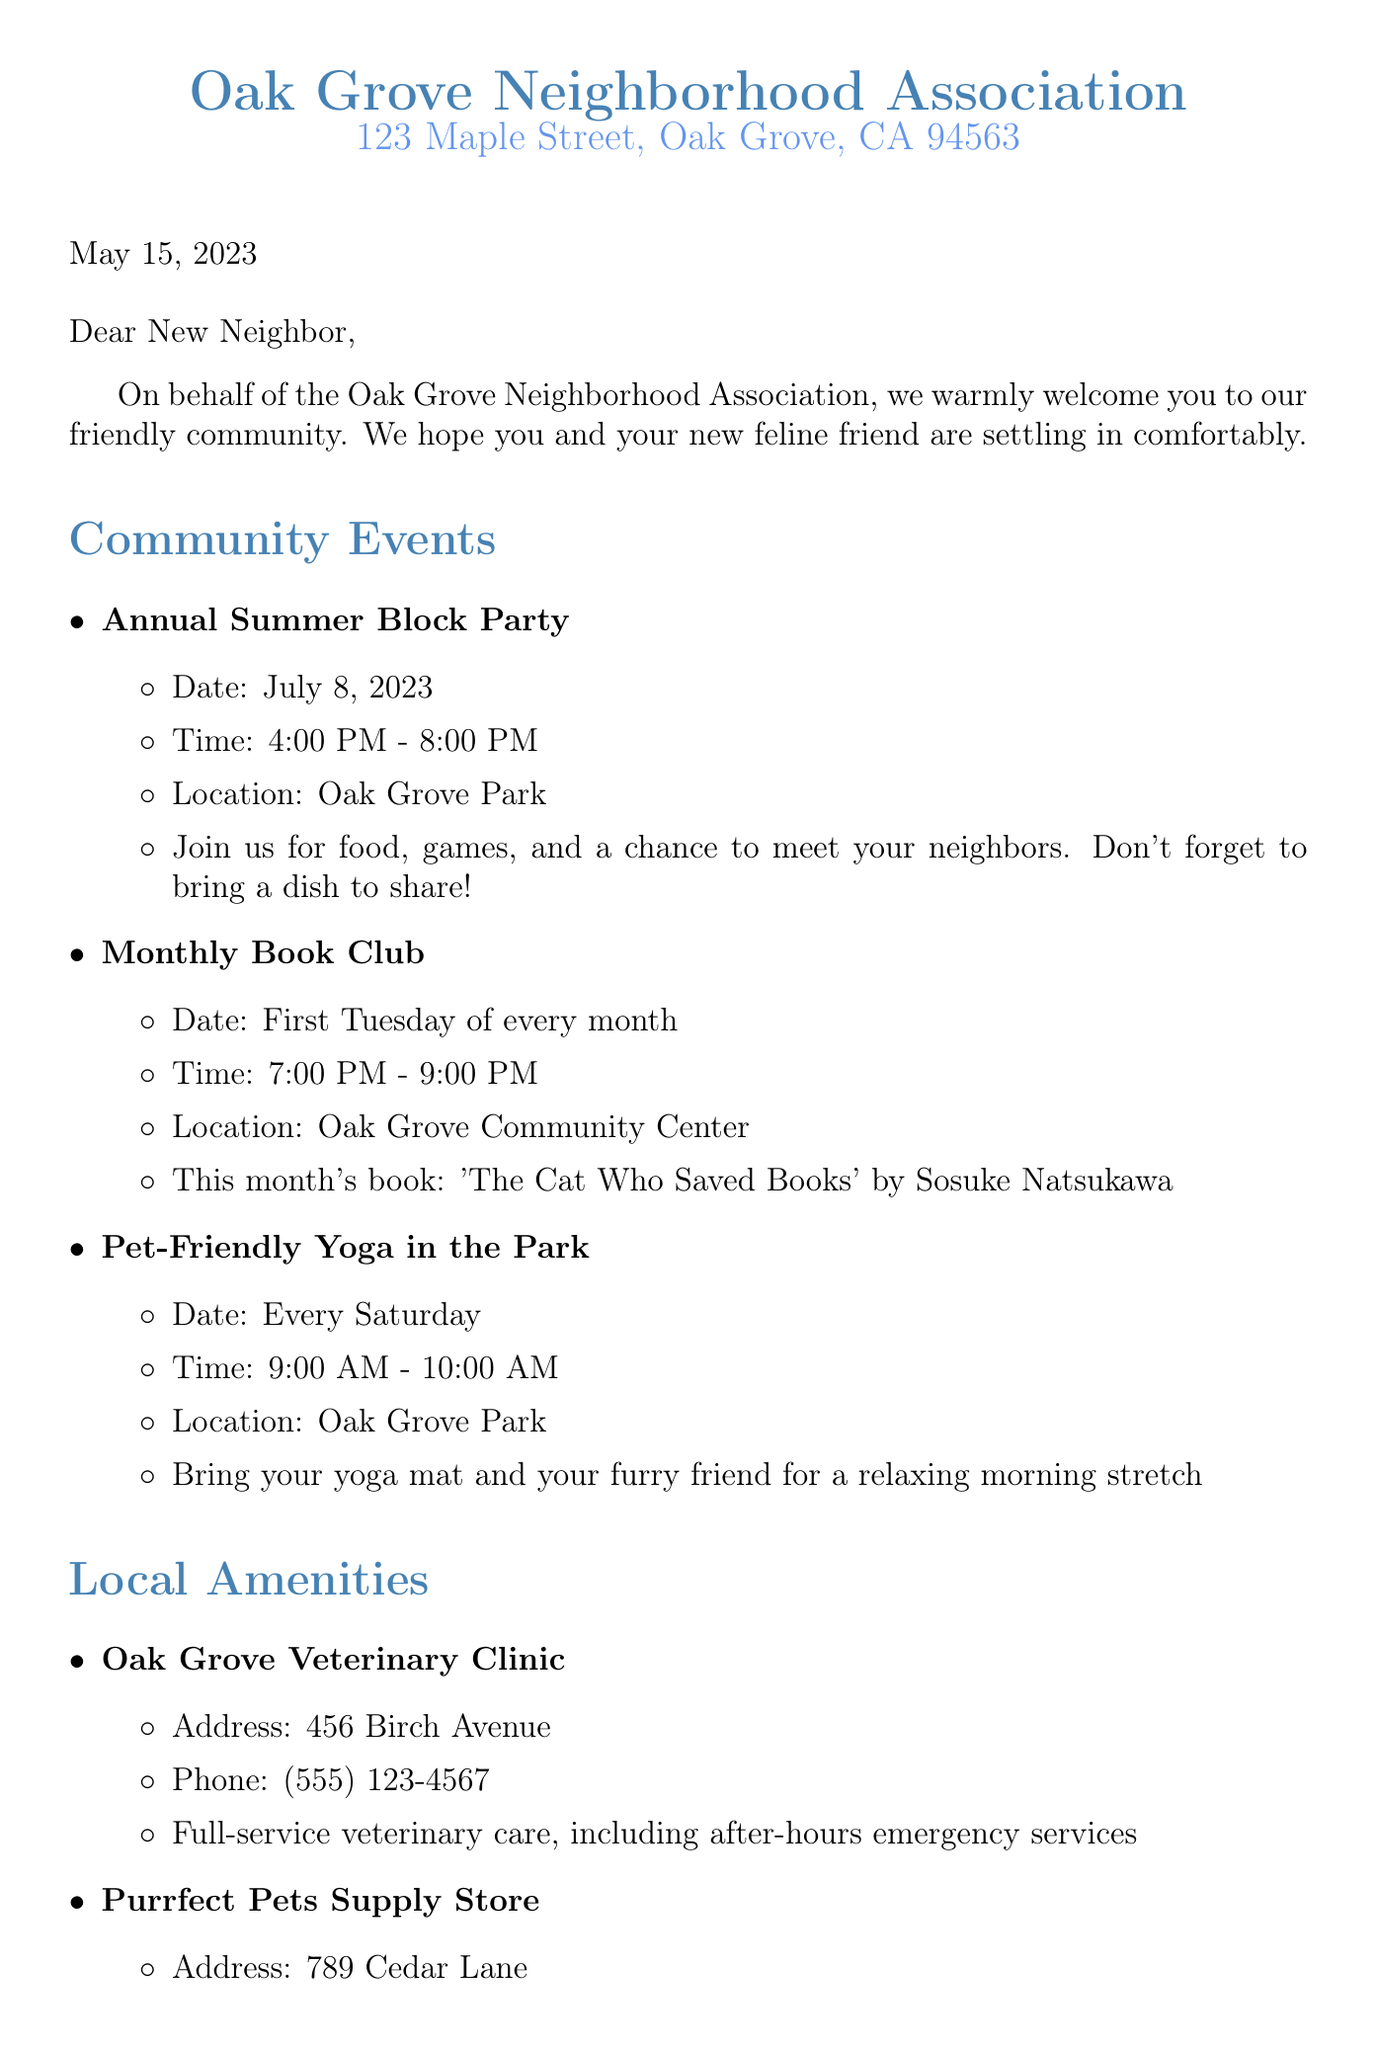What is the name of the neighborhood association? The document states that the name of the association is "Oak Grove Neighborhood Association."
Answer: Oak Grove Neighborhood Association What is the date of the Annual Summer Block Party? The document indicates that the Annual Summer Block Party is scheduled for July 8, 2023.
Answer: July 8, 2023 When does the Monthly Book Club meet? According to the document, the Monthly Book Club meets on the first Tuesday of every month.
Answer: First Tuesday of every month What location hosts the Pet-Friendly Yoga in the Park? The document specifies that the Pet-Friendly Yoga in the Park takes place at Oak Grove Park.
Answer: Oak Grove Park What is the address of the Oak Grove Veterinary Clinic? The Oak Grove Veterinary Clinic is located at 456 Birch Avenue, as stated in the document.
Answer: 456 Birch Avenue Why might the Whiskers Cat Cafe be of interest to a new cat owner? The document mentions that Whiskers Cat Cafe allows visitors to enjoy coffee while socializing with adoptable cats, which could be appealing for new cat owners.
Answer: Socializing with adoptable cats What service does the Oak Grove Community Center offer for new pet owners? The Oak Grove Community Center offers a "New Pet Owner" workshop series, as mentioned in the document, which could be very useful for someone new to pet ownership.
Answer: New Pet Owner workshop series What is the purpose of the Oak Grove Farmers Market? The document describes the Oak Grove Farmers Market as a venue for fresh produce, artisanal goods, and local pet treat vendors, making it an important resource for community engagement.
Answer: Fresh produce and artisanal goods Who is the President of the Oak Grove Neighborhood Association? The document identifies Emily Thompson as the President of the Oak Grove Neighborhood Association.
Answer: Emily Thompson 